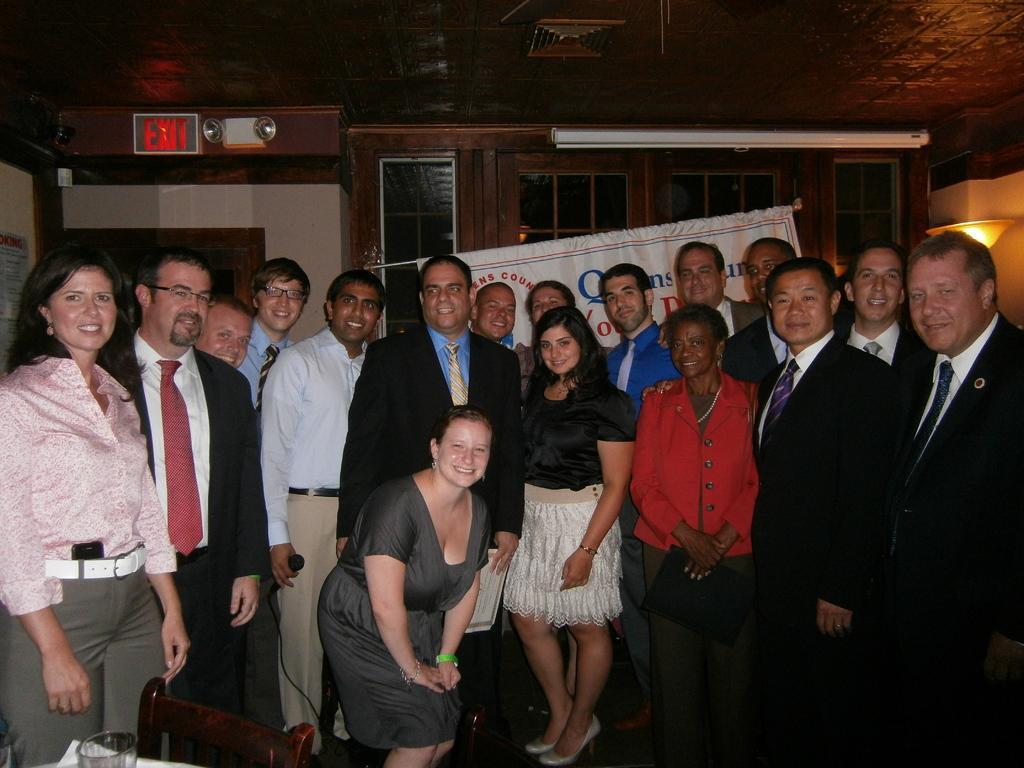Could you give a brief overview of what you see in this image? In this image we can see two persons. One person Is holding a phone in his hand. A woman is holding a bottle in her hand and standing in front of a table on which group of bottles, papers are placed. 